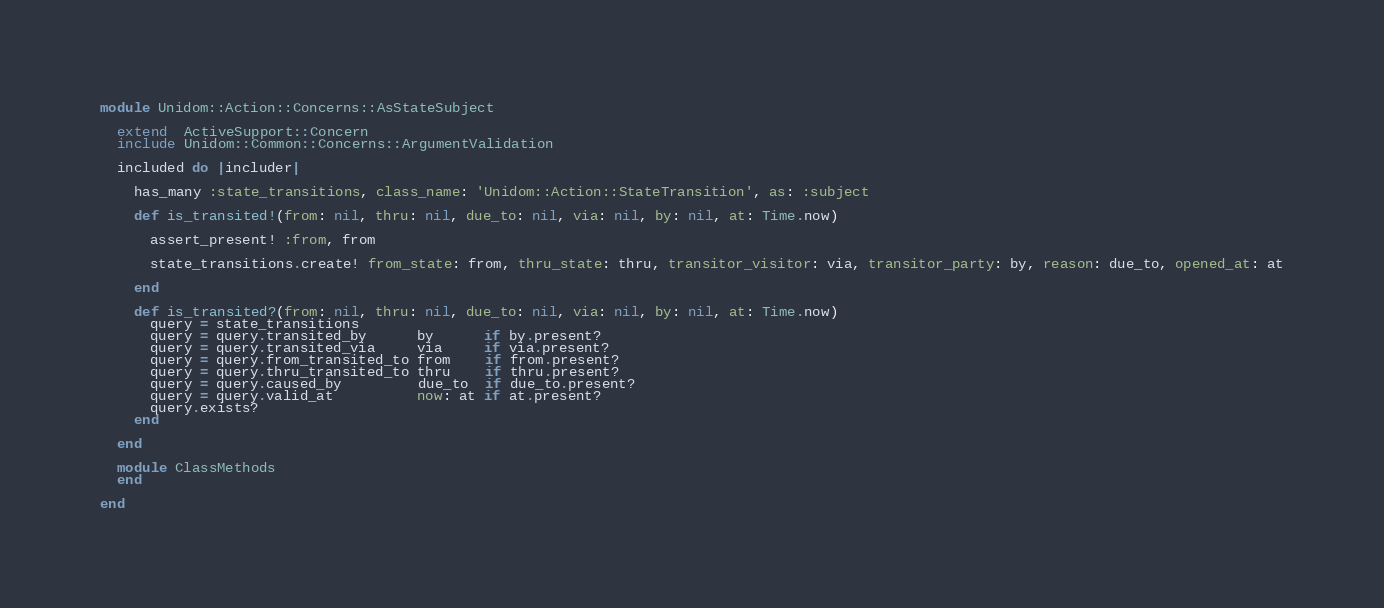Convert code to text. <code><loc_0><loc_0><loc_500><loc_500><_Ruby_>module Unidom::Action::Concerns::AsStateSubject

  extend  ActiveSupport::Concern
  include Unidom::Common::Concerns::ArgumentValidation

  included do |includer|

    has_many :state_transitions, class_name: 'Unidom::Action::StateTransition', as: :subject

    def is_transited!(from: nil, thru: nil, due_to: nil, via: nil, by: nil, at: Time.now)

      assert_present! :from, from

      state_transitions.create! from_state: from, thru_state: thru, transitor_visitor: via, transitor_party: by, reason: due_to, opened_at: at

    end

    def is_transited?(from: nil, thru: nil, due_to: nil, via: nil, by: nil, at: Time.now)
      query = state_transitions
      query = query.transited_by      by      if by.present?
      query = query.transited_via     via     if via.present?
      query = query.from_transited_to from    if from.present?
      query = query.thru_transited_to thru    if thru.present?
      query = query.caused_by         due_to  if due_to.present?
      query = query.valid_at          now: at if at.present?
      query.exists?
    end

  end

  module ClassMethods
  end

end
</code> 